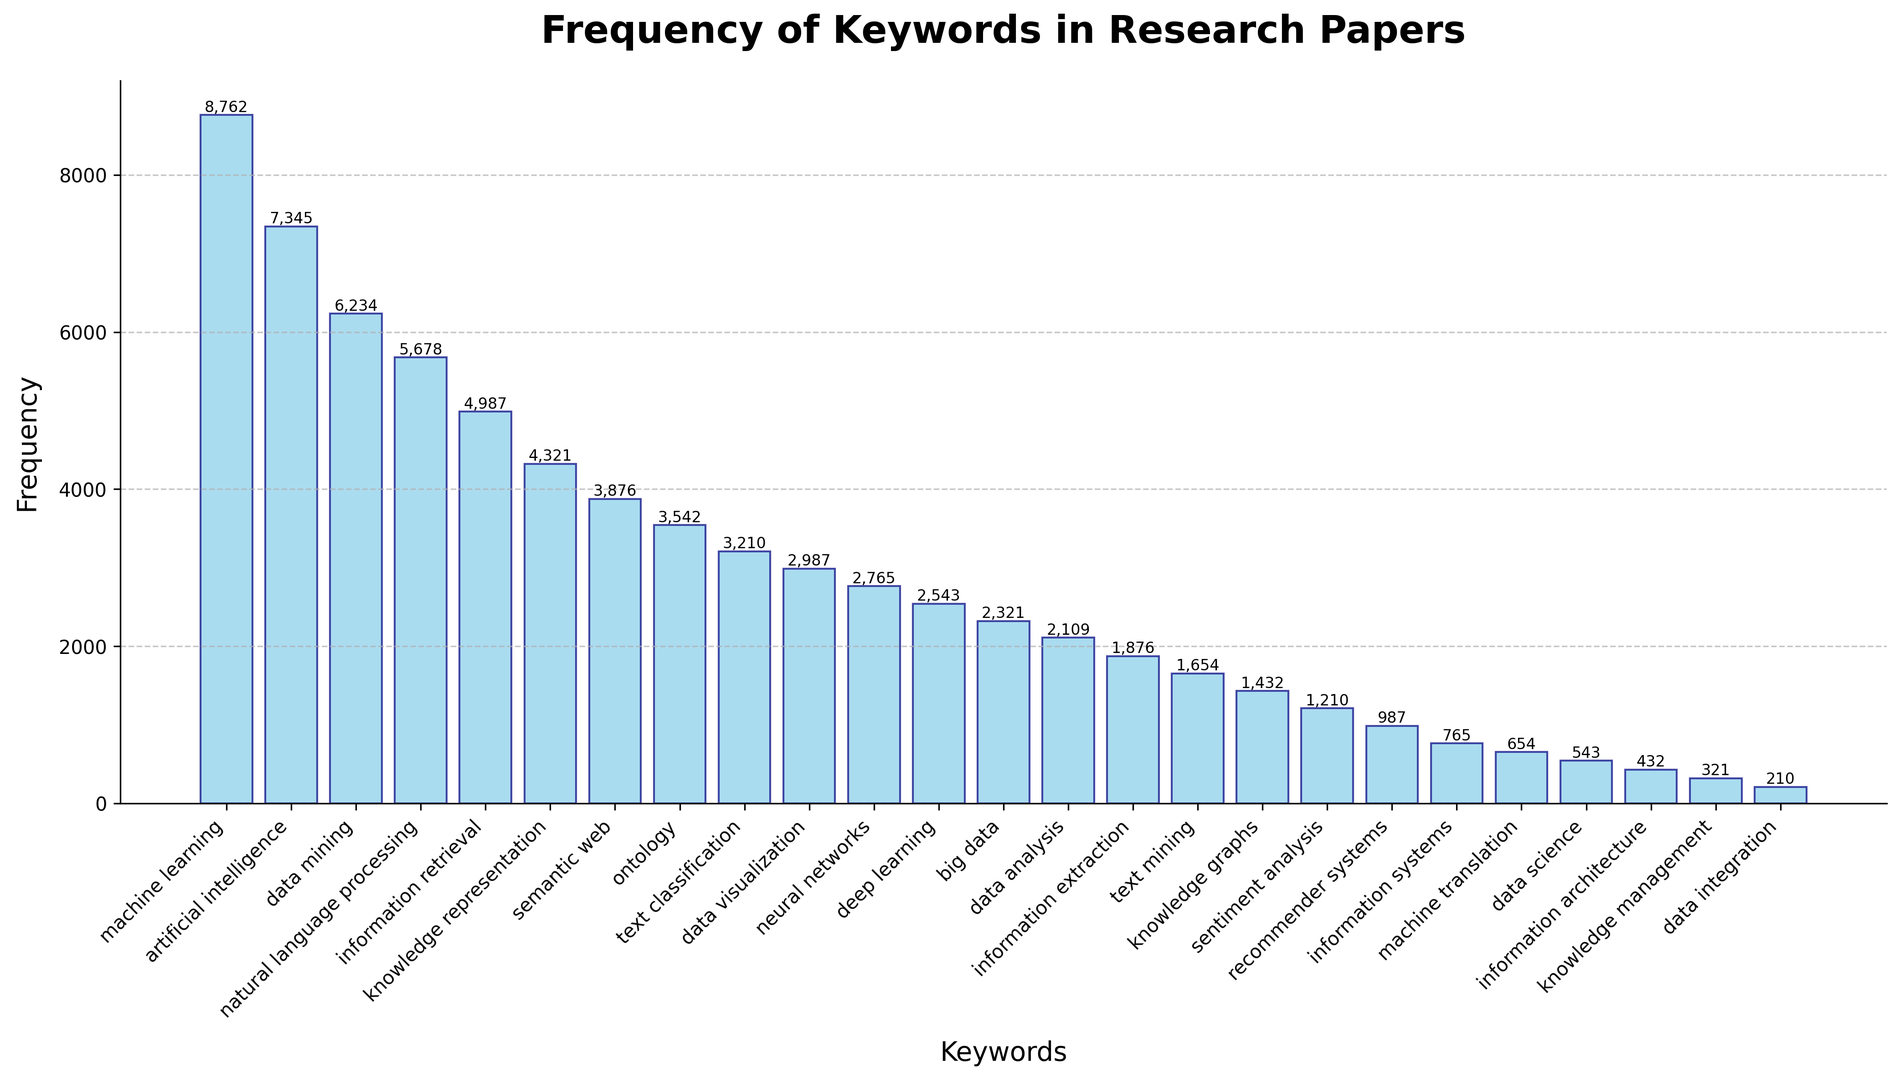What keyword has the highest frequency? The tallest bar in the histogram represents the keyword with the highest frequency. The keyword is labeled at the x-axis directly beneath the tallest bar.
Answer: "machine learning" Which keyword has a lower frequency: "natural language processing" or "data mining"? Locate both keywords on the x-axis and compare the heights of their respective bars. The shorter bar indicates the lower frequency.
Answer: "natural language processing" What's the combined frequency of the keywords "deep learning" and "neural networks"? Identify the bars corresponding to "deep learning" and "neural networks" on the x-axis, then sum their heights. "deep learning" has 2543 and "neural networks" has 2765. So, 2543 + 2765 = 5308
Answer: 5308 How much more frequent is "big data" compared to "data science"? Find the heights of the bars representing "big data" and "data science". Subtract the frequency of "data science" (543) from the frequency of "big data" (2321). So, 2321 - 543 = 1778
Answer: 1778 What is the average frequency of the five least frequent keywords? Identify the bars of the five least frequent keywords and their frequencies: "knowledge management" (321), "data integration" (210), "information architecture" (432), "data science" (543), "machine translation" (654). Sum these frequencies and divide by 5. (321 + 210 + 432 + 543 + 654) / 5 = 2160 / 5 = 432
Answer: 432 What are the most and least frequent keywords related to "machine learning"? Identify the keywords involving "machine learning" in some form and compare their frequencies. Keywords include "machine learning" (8762) and "deep learning" (2543). The most frequent is "machine learning" (8762), and the least frequent is "deep learning" (2543).
Answer: Most: "machine learning"; Least: "deep learning" What is the frequency difference between "information extraction" and "knowledge graphs"? Find the heights of the bars for "information extraction" and "knowledge graphs." Subtract the frequency of "knowledge graphs" (1432) from "information extraction" (1876). So, 1876 - 1432 = 444
Answer: 444 Which keyword appears with a frequency most similar to "data visualization"? Find the frequency of "data visualization" (2987), then identify the bar with a frequency closest to this value. "text classification" has 3210, which is the closest.
Answer: "text classification" What percentage of the overall frequency does "artificial intelligence" contribute? Total the frequencies of all keywords. Calculate the frequency of "artificial intelligence" (7345) divided by the total frequency, then multiply by 100. Total frequency sum = 78980. Percentage = (7345 / 78980) * 100 = 9.30%
Answer: 9.30% What is the median frequency of all the keywords? Sort all frequencies in ascending order and find the middle value. Since there are 25 keywords, the median frequency is the 13th value when sorted. The sorted list gives the median as 3210.
Answer: 3210 